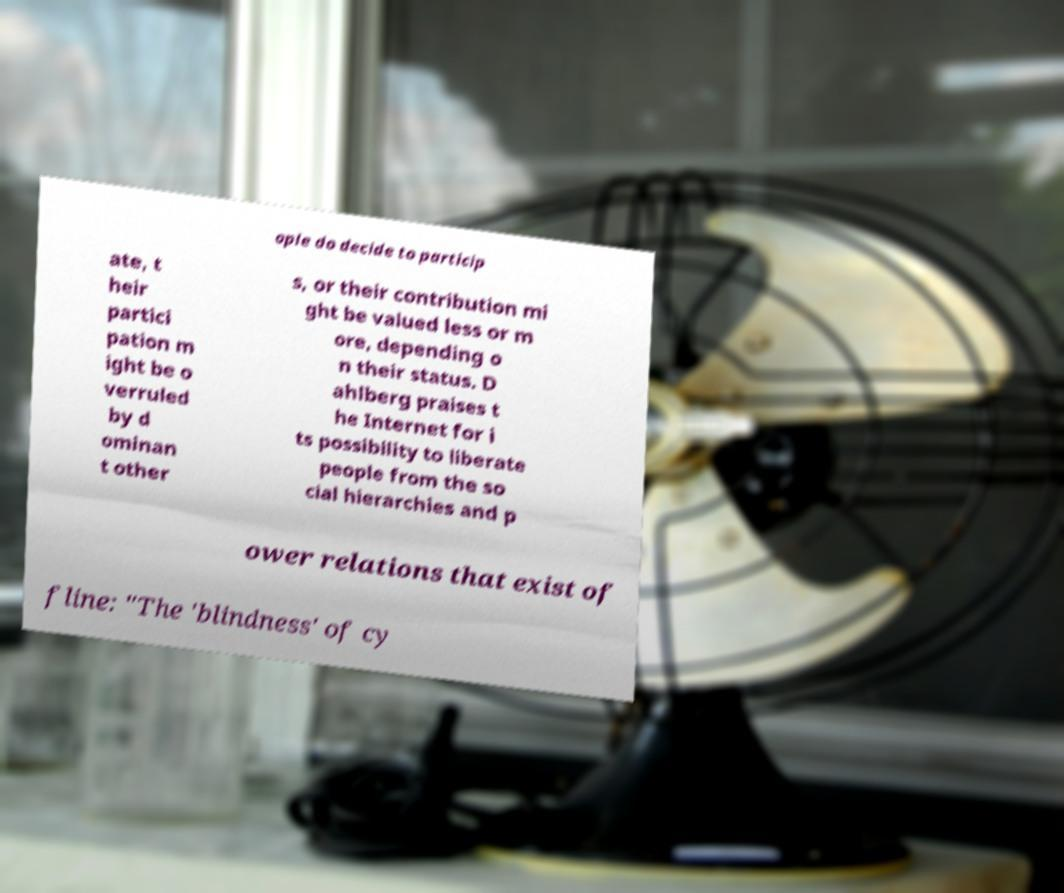I need the written content from this picture converted into text. Can you do that? ople do decide to particip ate, t heir partici pation m ight be o verruled by d ominan t other s, or their contribution mi ght be valued less or m ore, depending o n their status. D ahlberg praises t he Internet for i ts possibility to liberate people from the so cial hierarchies and p ower relations that exist of fline: "The 'blindness' of cy 